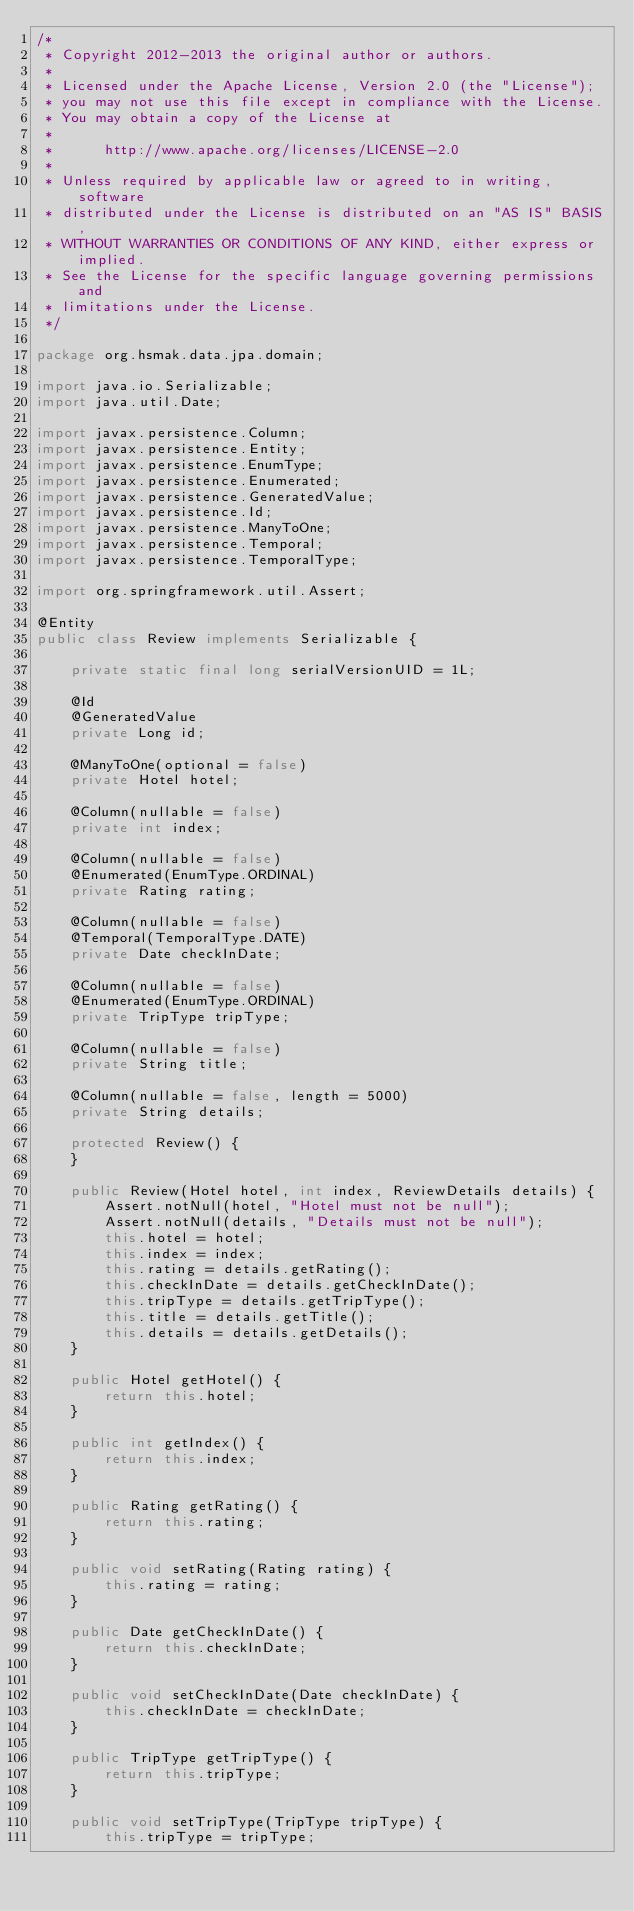<code> <loc_0><loc_0><loc_500><loc_500><_Java_>/*
 * Copyright 2012-2013 the original author or authors.
 *
 * Licensed under the Apache License, Version 2.0 (the "License");
 * you may not use this file except in compliance with the License.
 * You may obtain a copy of the License at
 *
 *      http://www.apache.org/licenses/LICENSE-2.0
 *
 * Unless required by applicable law or agreed to in writing, software
 * distributed under the License is distributed on an "AS IS" BASIS,
 * WITHOUT WARRANTIES OR CONDITIONS OF ANY KIND, either express or implied.
 * See the License for the specific language governing permissions and
 * limitations under the License.
 */

package org.hsmak.data.jpa.domain;

import java.io.Serializable;
import java.util.Date;

import javax.persistence.Column;
import javax.persistence.Entity;
import javax.persistence.EnumType;
import javax.persistence.Enumerated;
import javax.persistence.GeneratedValue;
import javax.persistence.Id;
import javax.persistence.ManyToOne;
import javax.persistence.Temporal;
import javax.persistence.TemporalType;

import org.springframework.util.Assert;

@Entity
public class Review implements Serializable {

	private static final long serialVersionUID = 1L;

	@Id
	@GeneratedValue
	private Long id;

	@ManyToOne(optional = false)
	private Hotel hotel;

	@Column(nullable = false)
	private int index;

	@Column(nullable = false)
	@Enumerated(EnumType.ORDINAL)
	private Rating rating;

	@Column(nullable = false)
	@Temporal(TemporalType.DATE)
	private Date checkInDate;

	@Column(nullable = false)
	@Enumerated(EnumType.ORDINAL)
	private TripType tripType;

	@Column(nullable = false)
	private String title;

	@Column(nullable = false, length = 5000)
	private String details;

	protected Review() {
	}

	public Review(Hotel hotel, int index, ReviewDetails details) {
		Assert.notNull(hotel, "Hotel must not be null");
		Assert.notNull(details, "Details must not be null");
		this.hotel = hotel;
		this.index = index;
		this.rating = details.getRating();
		this.checkInDate = details.getCheckInDate();
		this.tripType = details.getTripType();
		this.title = details.getTitle();
		this.details = details.getDetails();
	}

	public Hotel getHotel() {
		return this.hotel;
	}

	public int getIndex() {
		return this.index;
	}

	public Rating getRating() {
		return this.rating;
	}

	public void setRating(Rating rating) {
		this.rating = rating;
	}

	public Date getCheckInDate() {
		return this.checkInDate;
	}

	public void setCheckInDate(Date checkInDate) {
		this.checkInDate = checkInDate;
	}

	public TripType getTripType() {
		return this.tripType;
	}

	public void setTripType(TripType tripType) {
		this.tripType = tripType;</code> 